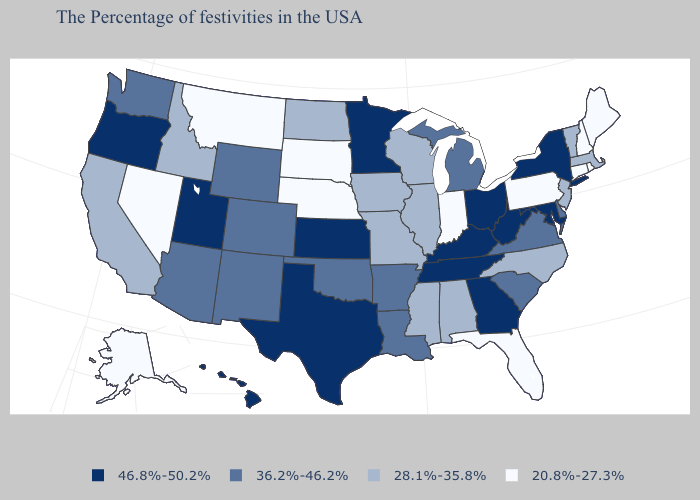Which states hav the highest value in the Northeast?
Answer briefly. New York. What is the highest value in the USA?
Give a very brief answer. 46.8%-50.2%. What is the lowest value in the Northeast?
Give a very brief answer. 20.8%-27.3%. What is the value of Tennessee?
Be succinct. 46.8%-50.2%. Is the legend a continuous bar?
Keep it brief. No. What is the lowest value in the South?
Quick response, please. 20.8%-27.3%. Among the states that border Colorado , which have the highest value?
Write a very short answer. Kansas, Utah. Does Oklahoma have the lowest value in the USA?
Give a very brief answer. No. Does Maryland have the lowest value in the South?
Answer briefly. No. Does New Mexico have the highest value in the West?
Short answer required. No. What is the value of Iowa?
Quick response, please. 28.1%-35.8%. Does the map have missing data?
Concise answer only. No. Name the states that have a value in the range 46.8%-50.2%?
Concise answer only. New York, Maryland, West Virginia, Ohio, Georgia, Kentucky, Tennessee, Minnesota, Kansas, Texas, Utah, Oregon, Hawaii. Does Nevada have a lower value than South Dakota?
Answer briefly. No. Among the states that border Iowa , which have the highest value?
Keep it brief. Minnesota. 